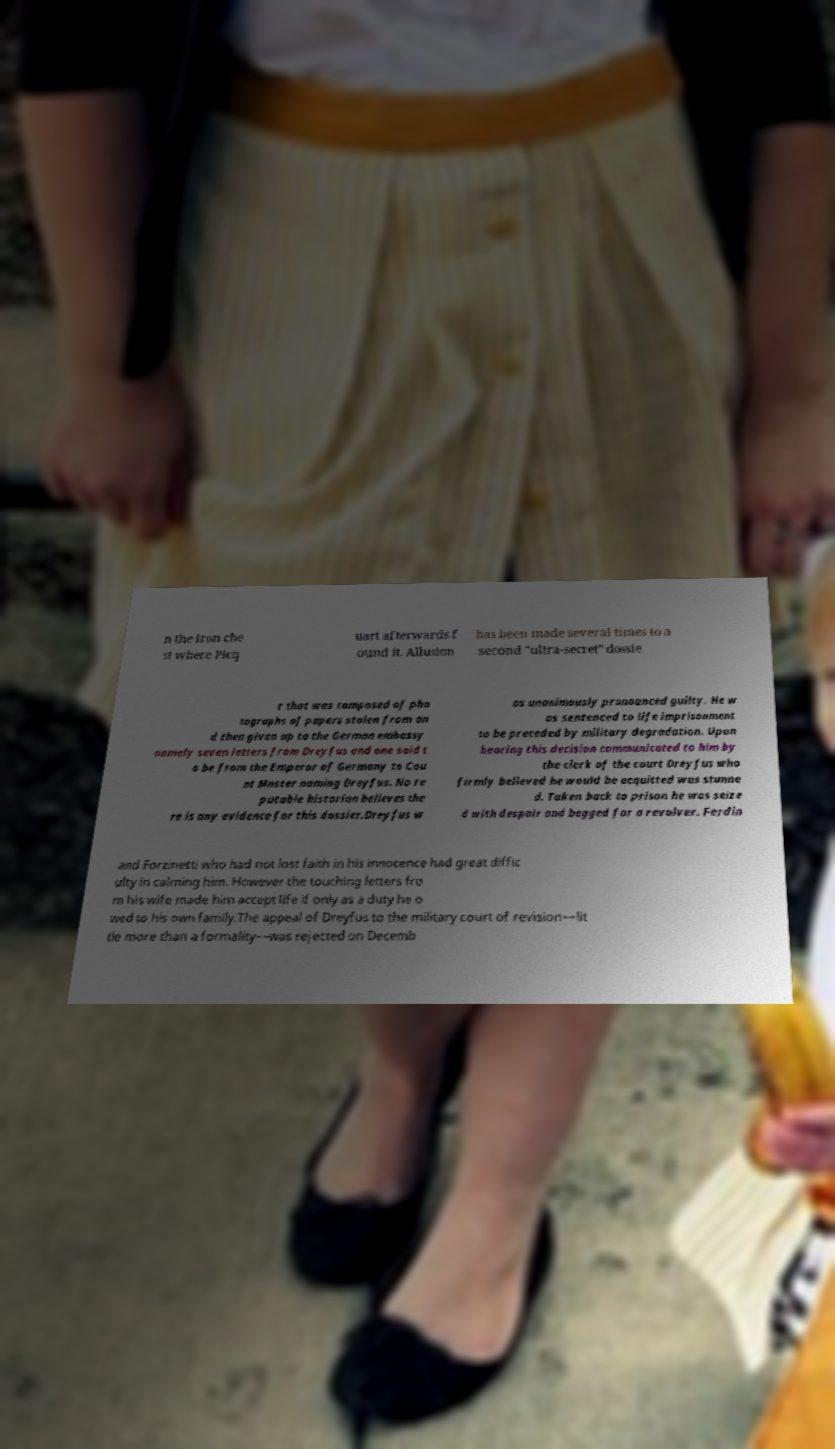I need the written content from this picture converted into text. Can you do that? n the iron che st where Picq uart afterwards f ound it. Allusion has been made several times to a second "ultra-secret” dossie r that was composed of pho tographs of papers stolen from an d then given up to the German embassy namely seven letters from Dreyfus and one said t o be from the Emperor of Germany to Cou nt Mnster naming Dreyfus. No re putable historian believes the re is any evidence for this dossier.Dreyfus w as unanimously pronounced guilty. He w as sentenced to life imprisonment to be preceded by military degradation. Upon hearing this decision communicated to him by the clerk of the court Dreyfus who firmly believed he would be acquitted was stunne d. Taken back to prison he was seize d with despair and begged for a revolver. Ferdin and Forzinetti who had not lost faith in his innocence had great diffic ulty in calming him. However the touching letters fro m his wife made him accept life if only as a duty he o wed to his own family.The appeal of Dreyfus to the military court of revision––lit tle more than a formality––was rejected on Decemb 